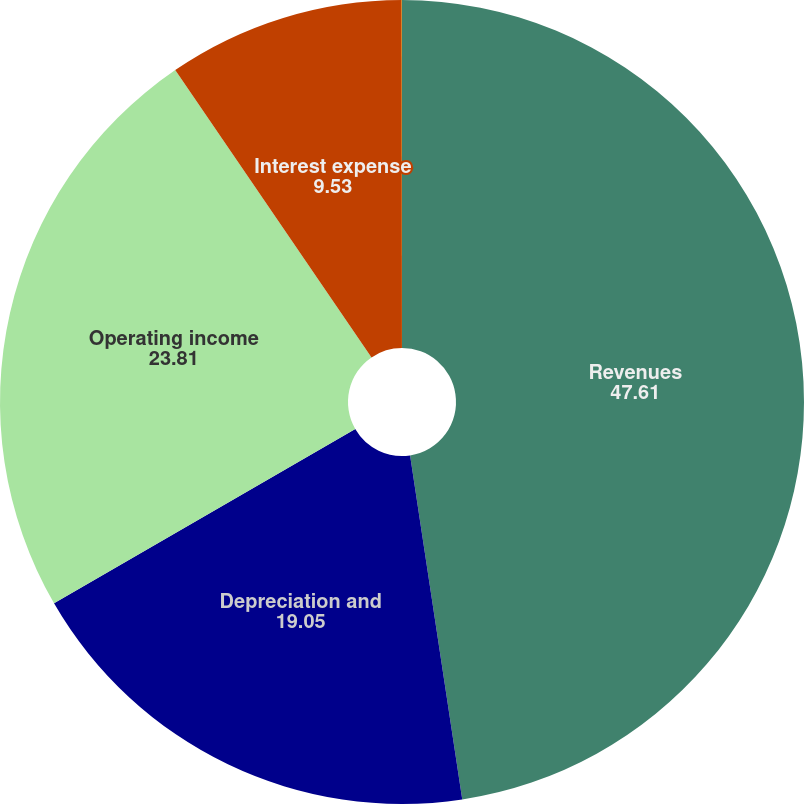Convert chart. <chart><loc_0><loc_0><loc_500><loc_500><pie_chart><fcel>Revenues<fcel>Depreciation and<fcel>Operating income<fcel>Interest expense<fcel>Income from continuing<nl><fcel>47.61%<fcel>19.05%<fcel>23.81%<fcel>9.53%<fcel>0.01%<nl></chart> 